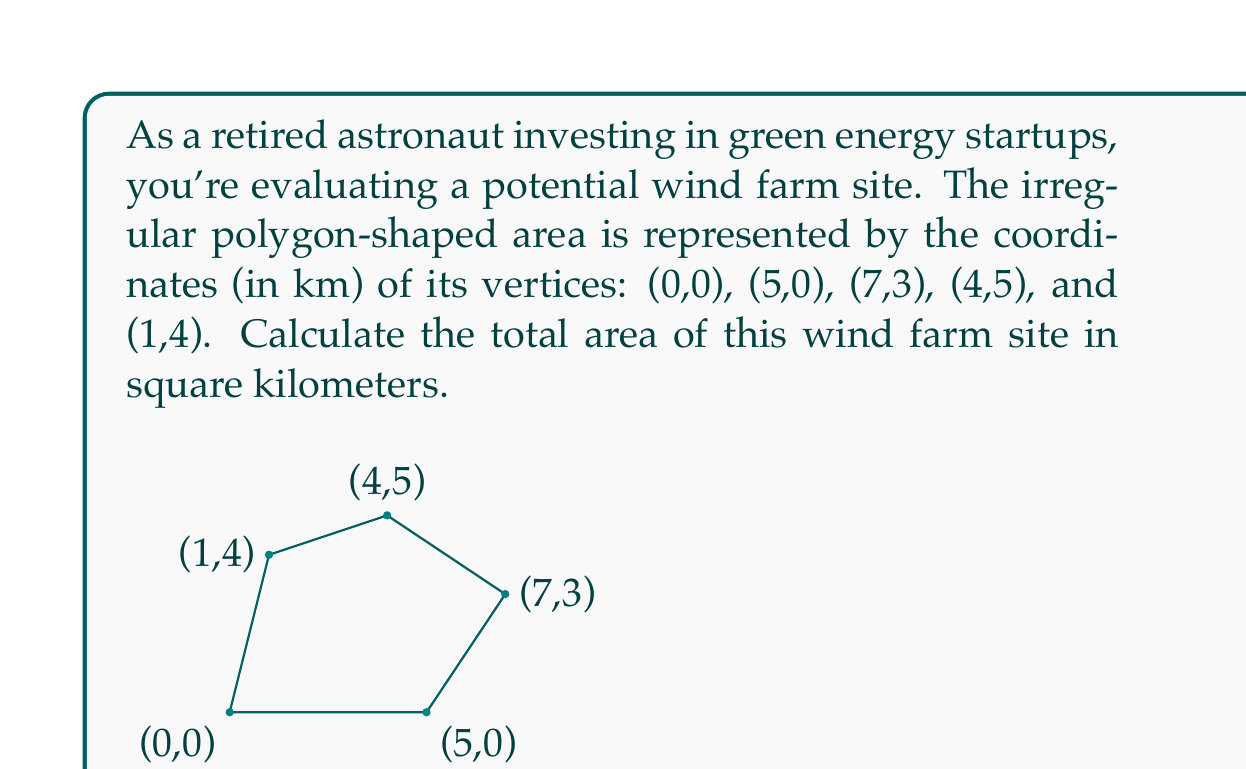Help me with this question. To find the area of this irregular polygon, we can use the Shoelace formula (also known as the surveyor's formula). The formula is:

$$ A = \frac{1}{2}|\sum_{i=1}^{n-1} (x_iy_{i+1} + x_ny_1) - \sum_{i=1}^{n-1} (y_ix_{i+1} + y_nx_1)| $$

Where $(x_i, y_i)$ are the coordinates of the $i$-th vertex.

Let's apply this formula step by step:

1) First, let's organize our vertices:
   $(x_1, y_1) = (0, 0)$
   $(x_2, y_2) = (5, 0)$
   $(x_3, y_3) = (7, 3)$
   $(x_4, y_4) = (4, 5)$
   $(x_5, y_5) = (1, 4)$

2) Now, let's calculate the first sum:
   $\sum_{i=1}^{n-1} (x_iy_{i+1} + x_ny_1)$
   $= (0 \cdot 0 + 5 \cdot 3 + 7 \cdot 5 + 4 \cdot 4 + 1 \cdot 0)$
   $= 0 + 15 + 35 + 16 + 0 = 66$

3) Next, let's calculate the second sum:
   $\sum_{i=1}^{n-1} (y_ix_{i+1} + y_nx_1)$
   $= (0 \cdot 5 + 0 \cdot 7 + 3 \cdot 4 + 5 \cdot 1 + 4 \cdot 0)$
   $= 0 + 0 + 12 + 5 + 0 = 17$

4) Now we can subtract these sums:
   $66 - 17 = 49$

5) Finally, we take the absolute value and divide by 2:
   $A = \frac{1}{2}|49| = 24.5$

Therefore, the area of the wind farm site is 24.5 square kilometers.
Answer: 24.5 km² 